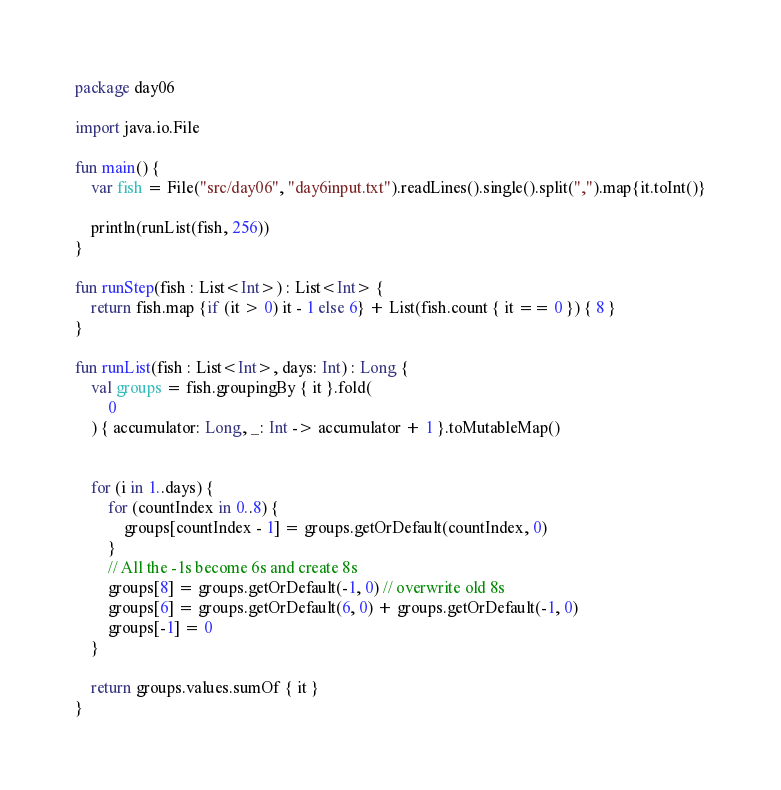<code> <loc_0><loc_0><loc_500><loc_500><_Kotlin_>package day06

import java.io.File

fun main() {
    var fish = File("src/day06", "day6input.txt").readLines().single().split(",").map{it.toInt()}

    println(runList(fish, 256))
}

fun runStep(fish : List<Int>) : List<Int> {
    return fish.map {if (it > 0) it - 1 else 6} + List(fish.count { it == 0 }) { 8 }
}

fun runList(fish : List<Int>, days: Int) : Long {
    val groups = fish.groupingBy { it }.fold(
        0
    ) { accumulator: Long, _: Int -> accumulator + 1 }.toMutableMap()


    for (i in 1..days) {
        for (countIndex in 0..8) {
            groups[countIndex - 1] = groups.getOrDefault(countIndex, 0)
        }
        // All the -1s become 6s and create 8s
        groups[8] = groups.getOrDefault(-1, 0) // overwrite old 8s
        groups[6] = groups.getOrDefault(6, 0) + groups.getOrDefault(-1, 0)
        groups[-1] = 0
    }

    return groups.values.sumOf { it }
}</code> 